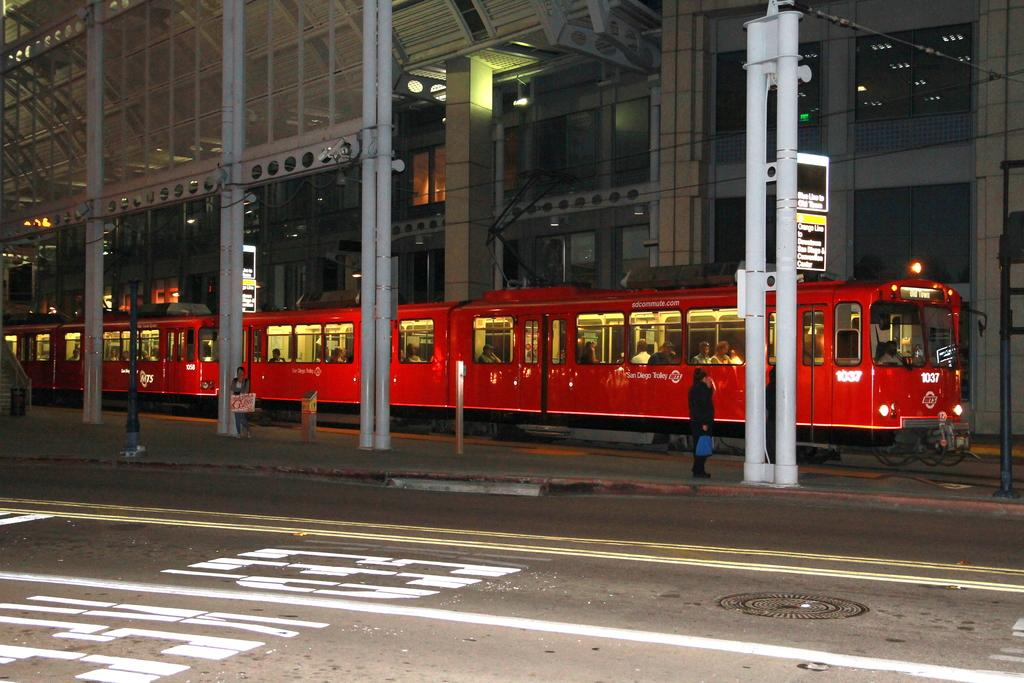What can be seen inside the train in the image? There is a group of people in the train. What is located beside the train? There are poles, sign boards, and lights beside the train. What is the color of the train? The train is red in color. What type of ornament is hanging from the ceiling of the train? There is no ornament hanging from the ceiling of the train in the image. Is there any milk being served to the passengers in the train? There is no indication of milk or any food being served in the image. 